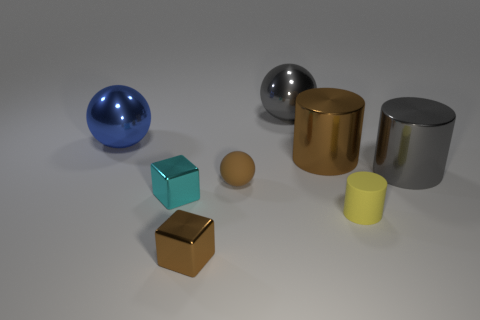The rubber ball that is the same size as the yellow rubber object is what color?
Give a very brief answer. Brown. Are there any big metallic spheres of the same color as the matte sphere?
Ensure brevity in your answer.  No. Are any red rubber balls visible?
Your answer should be compact. No. Is the object behind the large blue shiny sphere made of the same material as the tiny brown sphere?
Ensure brevity in your answer.  No. What is the size of the metal block that is the same color as the rubber sphere?
Offer a very short reply. Small. How many purple balls are the same size as the cyan cube?
Your response must be concise. 0. Are there an equal number of brown metallic things behind the tiny cyan cube and small blue matte blocks?
Provide a short and direct response. No. What number of shiny objects are both behind the small cyan object and in front of the cyan thing?
Offer a very short reply. 0. What is the size of the blue object that is made of the same material as the small cyan thing?
Offer a terse response. Large. What number of tiny cyan objects have the same shape as the yellow object?
Make the answer very short. 0. 